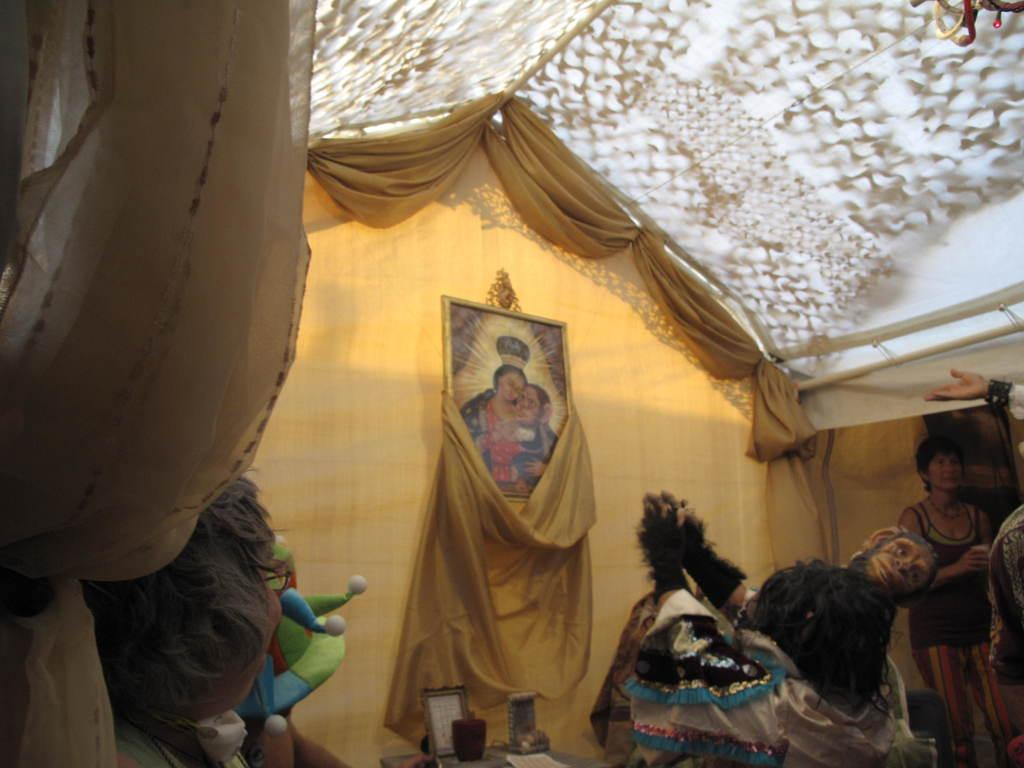How many people are in the image? There are people in the image, but the exact number is not specified. Can you describe the woman in the image? A woman is standing in the image. What is on the wall in the image? There is a frame on the wall in the image. What type of window treatment is present in the image? There are curtains in the image. What is the woman holding in the image? A spectacle is visible in the image. What type of headwear is present in the image? A cap is present in the image. What is the woman holding in her hand in the image? There is a paper in the image. Can you describe any other objects in the image? There are other objects in the image, but their specific details are not provided. How does the pig express regret in the image? There is no pig present in the image, so it cannot express any emotions, including regret. 